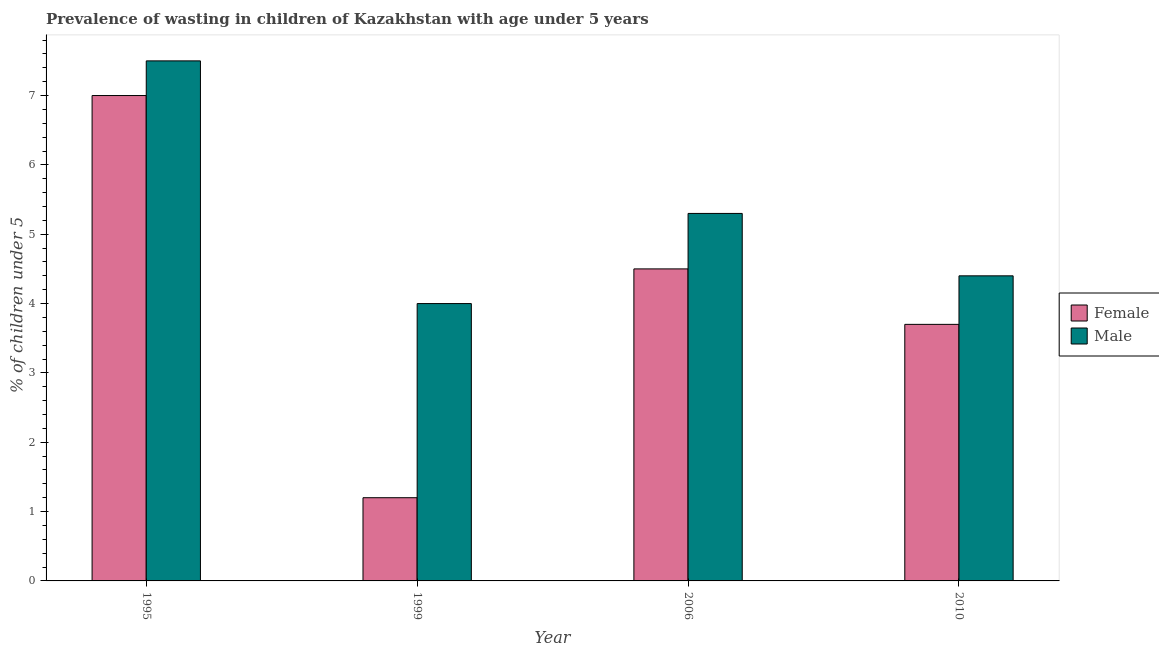What is the percentage of undernourished male children in 2006?
Provide a succinct answer. 5.3. Across all years, what is the minimum percentage of undernourished male children?
Offer a very short reply. 4. What is the total percentage of undernourished female children in the graph?
Offer a terse response. 16.4. What is the difference between the percentage of undernourished female children in 1995 and that in 2010?
Your answer should be very brief. 3.3. What is the difference between the percentage of undernourished female children in 2010 and the percentage of undernourished male children in 1999?
Your answer should be very brief. 2.5. What is the average percentage of undernourished female children per year?
Your response must be concise. 4.1. What is the ratio of the percentage of undernourished male children in 1995 to that in 1999?
Your answer should be very brief. 1.88. Is the difference between the percentage of undernourished female children in 1995 and 2006 greater than the difference between the percentage of undernourished male children in 1995 and 2006?
Give a very brief answer. No. What does the 2nd bar from the left in 1999 represents?
Your answer should be compact. Male. Are all the bars in the graph horizontal?
Offer a terse response. No. How many years are there in the graph?
Ensure brevity in your answer.  4. What is the difference between two consecutive major ticks on the Y-axis?
Give a very brief answer. 1. Are the values on the major ticks of Y-axis written in scientific E-notation?
Your answer should be compact. No. Does the graph contain any zero values?
Your answer should be compact. No. Where does the legend appear in the graph?
Make the answer very short. Center right. How many legend labels are there?
Your answer should be very brief. 2. How are the legend labels stacked?
Your answer should be compact. Vertical. What is the title of the graph?
Your answer should be very brief. Prevalence of wasting in children of Kazakhstan with age under 5 years. Does "Broad money growth" appear as one of the legend labels in the graph?
Give a very brief answer. No. What is the label or title of the X-axis?
Offer a very short reply. Year. What is the label or title of the Y-axis?
Make the answer very short.  % of children under 5. What is the  % of children under 5 of Female in 1995?
Your answer should be very brief. 7. What is the  % of children under 5 in Female in 1999?
Give a very brief answer. 1.2. What is the  % of children under 5 of Male in 2006?
Your answer should be compact. 5.3. What is the  % of children under 5 of Female in 2010?
Your answer should be compact. 3.7. What is the  % of children under 5 of Male in 2010?
Your answer should be compact. 4.4. Across all years, what is the maximum  % of children under 5 of Female?
Your response must be concise. 7. Across all years, what is the maximum  % of children under 5 of Male?
Your answer should be very brief. 7.5. Across all years, what is the minimum  % of children under 5 of Female?
Ensure brevity in your answer.  1.2. What is the total  % of children under 5 of Female in the graph?
Offer a terse response. 16.4. What is the total  % of children under 5 of Male in the graph?
Provide a short and direct response. 21.2. What is the difference between the  % of children under 5 of Female in 1995 and that in 1999?
Make the answer very short. 5.8. What is the difference between the  % of children under 5 in Male in 1995 and that in 1999?
Your answer should be very brief. 3.5. What is the difference between the  % of children under 5 in Male in 1995 and that in 2010?
Offer a terse response. 3.1. What is the difference between the  % of children under 5 of Female in 1999 and that in 2006?
Provide a succinct answer. -3.3. What is the difference between the  % of children under 5 in Male in 1999 and that in 2006?
Your response must be concise. -1.3. What is the difference between the  % of children under 5 in Female in 1999 and that in 2010?
Give a very brief answer. -2.5. What is the difference between the  % of children under 5 of Female in 2006 and that in 2010?
Ensure brevity in your answer.  0.8. What is the difference between the  % of children under 5 of Male in 2006 and that in 2010?
Ensure brevity in your answer.  0.9. What is the difference between the  % of children under 5 in Female in 1995 and the  % of children under 5 in Male in 2006?
Make the answer very short. 1.7. What is the difference between the  % of children under 5 of Female in 1999 and the  % of children under 5 of Male in 2010?
Your response must be concise. -3.2. In the year 1995, what is the difference between the  % of children under 5 of Female and  % of children under 5 of Male?
Provide a short and direct response. -0.5. In the year 1999, what is the difference between the  % of children under 5 of Female and  % of children under 5 of Male?
Offer a terse response. -2.8. In the year 2006, what is the difference between the  % of children under 5 in Female and  % of children under 5 in Male?
Give a very brief answer. -0.8. What is the ratio of the  % of children under 5 in Female in 1995 to that in 1999?
Keep it short and to the point. 5.83. What is the ratio of the  % of children under 5 in Male in 1995 to that in 1999?
Offer a terse response. 1.88. What is the ratio of the  % of children under 5 in Female in 1995 to that in 2006?
Offer a terse response. 1.56. What is the ratio of the  % of children under 5 of Male in 1995 to that in 2006?
Provide a short and direct response. 1.42. What is the ratio of the  % of children under 5 in Female in 1995 to that in 2010?
Offer a terse response. 1.89. What is the ratio of the  % of children under 5 of Male in 1995 to that in 2010?
Offer a very short reply. 1.7. What is the ratio of the  % of children under 5 in Female in 1999 to that in 2006?
Provide a short and direct response. 0.27. What is the ratio of the  % of children under 5 of Male in 1999 to that in 2006?
Keep it short and to the point. 0.75. What is the ratio of the  % of children under 5 of Female in 1999 to that in 2010?
Offer a terse response. 0.32. What is the ratio of the  % of children under 5 in Male in 1999 to that in 2010?
Ensure brevity in your answer.  0.91. What is the ratio of the  % of children under 5 in Female in 2006 to that in 2010?
Offer a terse response. 1.22. What is the ratio of the  % of children under 5 of Male in 2006 to that in 2010?
Keep it short and to the point. 1.2. What is the difference between the highest and the lowest  % of children under 5 in Female?
Make the answer very short. 5.8. What is the difference between the highest and the lowest  % of children under 5 of Male?
Give a very brief answer. 3.5. 